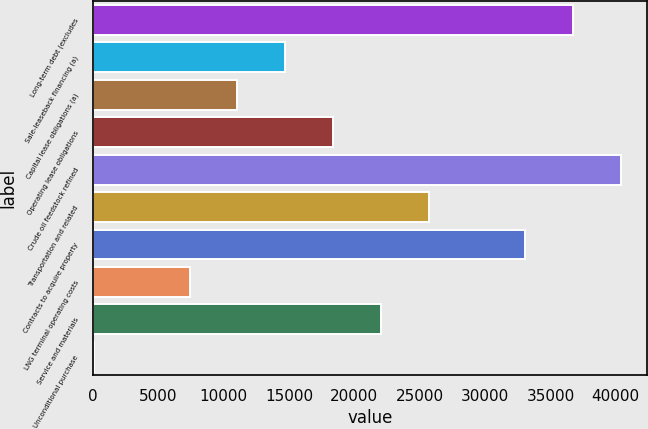Convert chart to OTSL. <chart><loc_0><loc_0><loc_500><loc_500><bar_chart><fcel>Long-term debt (excludes<fcel>Sale-leaseback financing (a)<fcel>Capital lease obligations (a)<fcel>Operating lease obligations<fcel>Crude oil feedstock refined<fcel>Transportation and related<fcel>Contracts to acquire property<fcel>LNG terminal operating costs<fcel>Service and materials<fcel>Unconditional purchase<nl><fcel>36708<fcel>14718.6<fcel>11053.7<fcel>18383.5<fcel>40372.9<fcel>25713.3<fcel>33043.1<fcel>7388.8<fcel>22048.4<fcel>59<nl></chart> 